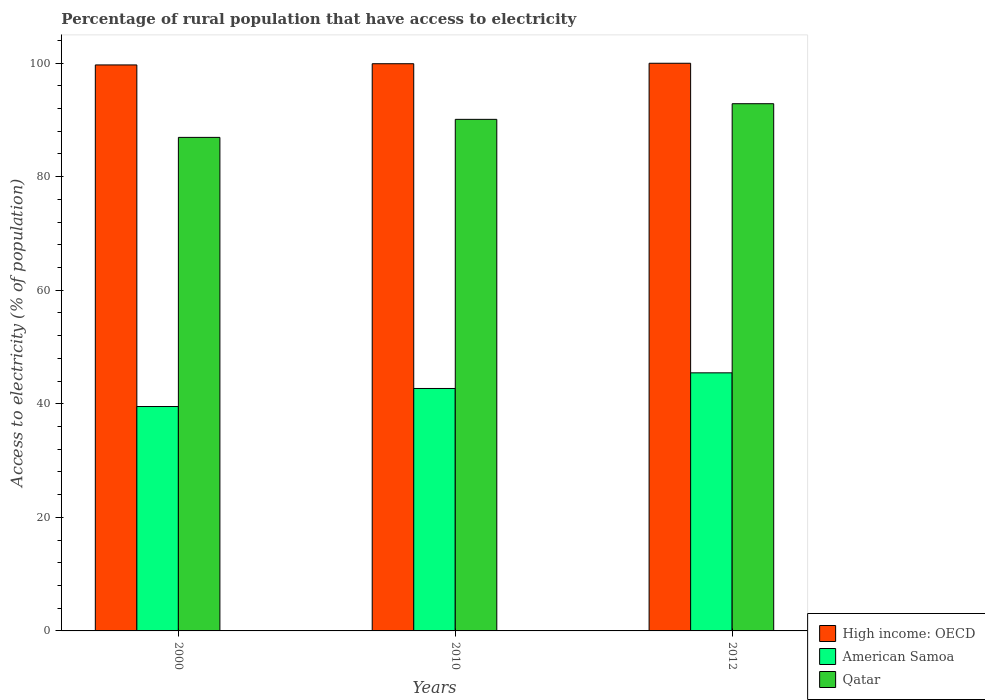How many groups of bars are there?
Ensure brevity in your answer.  3. What is the label of the 2nd group of bars from the left?
Keep it short and to the point. 2010. What is the percentage of rural population that have access to electricity in High income: OECD in 2012?
Ensure brevity in your answer.  99.98. Across all years, what is the maximum percentage of rural population that have access to electricity in American Samoa?
Keep it short and to the point. 45.45. Across all years, what is the minimum percentage of rural population that have access to electricity in American Samoa?
Make the answer very short. 39.52. What is the total percentage of rural population that have access to electricity in American Samoa in the graph?
Keep it short and to the point. 127.68. What is the difference between the percentage of rural population that have access to electricity in High income: OECD in 2010 and that in 2012?
Provide a short and direct response. -0.08. What is the difference between the percentage of rural population that have access to electricity in High income: OECD in 2010 and the percentage of rural population that have access to electricity in Qatar in 2012?
Your response must be concise. 7.04. What is the average percentage of rural population that have access to electricity in American Samoa per year?
Give a very brief answer. 42.56. In the year 2012, what is the difference between the percentage of rural population that have access to electricity in Qatar and percentage of rural population that have access to electricity in High income: OECD?
Keep it short and to the point. -7.13. In how many years, is the percentage of rural population that have access to electricity in High income: OECD greater than 80 %?
Offer a very short reply. 3. What is the ratio of the percentage of rural population that have access to electricity in High income: OECD in 2000 to that in 2010?
Make the answer very short. 1. What is the difference between the highest and the second highest percentage of rural population that have access to electricity in Qatar?
Provide a short and direct response. 2.75. What is the difference between the highest and the lowest percentage of rural population that have access to electricity in High income: OECD?
Offer a terse response. 0.3. What does the 2nd bar from the left in 2010 represents?
Offer a terse response. American Samoa. What does the 3rd bar from the right in 2000 represents?
Offer a very short reply. High income: OECD. Is it the case that in every year, the sum of the percentage of rural population that have access to electricity in Qatar and percentage of rural population that have access to electricity in High income: OECD is greater than the percentage of rural population that have access to electricity in American Samoa?
Keep it short and to the point. Yes. Are all the bars in the graph horizontal?
Provide a short and direct response. No. Are the values on the major ticks of Y-axis written in scientific E-notation?
Provide a short and direct response. No. How many legend labels are there?
Provide a short and direct response. 3. What is the title of the graph?
Provide a short and direct response. Percentage of rural population that have access to electricity. Does "Zimbabwe" appear as one of the legend labels in the graph?
Give a very brief answer. No. What is the label or title of the X-axis?
Provide a succinct answer. Years. What is the label or title of the Y-axis?
Your answer should be compact. Access to electricity (% of population). What is the Access to electricity (% of population) of High income: OECD in 2000?
Give a very brief answer. 99.68. What is the Access to electricity (% of population) in American Samoa in 2000?
Keep it short and to the point. 39.52. What is the Access to electricity (% of population) of Qatar in 2000?
Give a very brief answer. 86.93. What is the Access to electricity (% of population) of High income: OECD in 2010?
Make the answer very short. 99.9. What is the Access to electricity (% of population) of American Samoa in 2010?
Provide a succinct answer. 42.7. What is the Access to electricity (% of population) of Qatar in 2010?
Offer a terse response. 90.1. What is the Access to electricity (% of population) in High income: OECD in 2012?
Give a very brief answer. 99.98. What is the Access to electricity (% of population) of American Samoa in 2012?
Offer a terse response. 45.45. What is the Access to electricity (% of population) of Qatar in 2012?
Offer a terse response. 92.85. Across all years, what is the maximum Access to electricity (% of population) of High income: OECD?
Give a very brief answer. 99.98. Across all years, what is the maximum Access to electricity (% of population) in American Samoa?
Keep it short and to the point. 45.45. Across all years, what is the maximum Access to electricity (% of population) in Qatar?
Make the answer very short. 92.85. Across all years, what is the minimum Access to electricity (% of population) of High income: OECD?
Ensure brevity in your answer.  99.68. Across all years, what is the minimum Access to electricity (% of population) of American Samoa?
Offer a very short reply. 39.52. Across all years, what is the minimum Access to electricity (% of population) of Qatar?
Your response must be concise. 86.93. What is the total Access to electricity (% of population) in High income: OECD in the graph?
Your response must be concise. 299.56. What is the total Access to electricity (% of population) of American Samoa in the graph?
Make the answer very short. 127.68. What is the total Access to electricity (% of population) in Qatar in the graph?
Make the answer very short. 269.88. What is the difference between the Access to electricity (% of population) in High income: OECD in 2000 and that in 2010?
Keep it short and to the point. -0.21. What is the difference between the Access to electricity (% of population) of American Samoa in 2000 and that in 2010?
Offer a terse response. -3.18. What is the difference between the Access to electricity (% of population) of Qatar in 2000 and that in 2010?
Provide a succinct answer. -3.17. What is the difference between the Access to electricity (% of population) in High income: OECD in 2000 and that in 2012?
Provide a succinct answer. -0.3. What is the difference between the Access to electricity (% of population) in American Samoa in 2000 and that in 2012?
Give a very brief answer. -5.93. What is the difference between the Access to electricity (% of population) in Qatar in 2000 and that in 2012?
Make the answer very short. -5.93. What is the difference between the Access to electricity (% of population) in High income: OECD in 2010 and that in 2012?
Provide a short and direct response. -0.08. What is the difference between the Access to electricity (% of population) in American Samoa in 2010 and that in 2012?
Offer a terse response. -2.75. What is the difference between the Access to electricity (% of population) of Qatar in 2010 and that in 2012?
Offer a terse response. -2.75. What is the difference between the Access to electricity (% of population) in High income: OECD in 2000 and the Access to electricity (% of population) in American Samoa in 2010?
Keep it short and to the point. 56.98. What is the difference between the Access to electricity (% of population) of High income: OECD in 2000 and the Access to electricity (% of population) of Qatar in 2010?
Give a very brief answer. 9.58. What is the difference between the Access to electricity (% of population) in American Samoa in 2000 and the Access to electricity (% of population) in Qatar in 2010?
Your answer should be very brief. -50.58. What is the difference between the Access to electricity (% of population) of High income: OECD in 2000 and the Access to electricity (% of population) of American Samoa in 2012?
Your answer should be very brief. 54.23. What is the difference between the Access to electricity (% of population) in High income: OECD in 2000 and the Access to electricity (% of population) in Qatar in 2012?
Ensure brevity in your answer.  6.83. What is the difference between the Access to electricity (% of population) in American Samoa in 2000 and the Access to electricity (% of population) in Qatar in 2012?
Make the answer very short. -53.33. What is the difference between the Access to electricity (% of population) of High income: OECD in 2010 and the Access to electricity (% of population) of American Samoa in 2012?
Provide a succinct answer. 54.44. What is the difference between the Access to electricity (% of population) in High income: OECD in 2010 and the Access to electricity (% of population) in Qatar in 2012?
Offer a terse response. 7.04. What is the difference between the Access to electricity (% of population) in American Samoa in 2010 and the Access to electricity (% of population) in Qatar in 2012?
Your answer should be very brief. -50.15. What is the average Access to electricity (% of population) in High income: OECD per year?
Provide a succinct answer. 99.85. What is the average Access to electricity (% of population) in American Samoa per year?
Offer a very short reply. 42.56. What is the average Access to electricity (% of population) of Qatar per year?
Your answer should be very brief. 89.96. In the year 2000, what is the difference between the Access to electricity (% of population) of High income: OECD and Access to electricity (% of population) of American Samoa?
Offer a terse response. 60.16. In the year 2000, what is the difference between the Access to electricity (% of population) in High income: OECD and Access to electricity (% of population) in Qatar?
Offer a very short reply. 12.76. In the year 2000, what is the difference between the Access to electricity (% of population) of American Samoa and Access to electricity (% of population) of Qatar?
Your response must be concise. -47.41. In the year 2010, what is the difference between the Access to electricity (% of population) in High income: OECD and Access to electricity (% of population) in American Samoa?
Give a very brief answer. 57.2. In the year 2010, what is the difference between the Access to electricity (% of population) in High income: OECD and Access to electricity (% of population) in Qatar?
Give a very brief answer. 9.8. In the year 2010, what is the difference between the Access to electricity (% of population) of American Samoa and Access to electricity (% of population) of Qatar?
Offer a very short reply. -47.4. In the year 2012, what is the difference between the Access to electricity (% of population) of High income: OECD and Access to electricity (% of population) of American Samoa?
Ensure brevity in your answer.  54.53. In the year 2012, what is the difference between the Access to electricity (% of population) in High income: OECD and Access to electricity (% of population) in Qatar?
Your answer should be very brief. 7.13. In the year 2012, what is the difference between the Access to electricity (% of population) in American Samoa and Access to electricity (% of population) in Qatar?
Keep it short and to the point. -47.4. What is the ratio of the Access to electricity (% of population) of American Samoa in 2000 to that in 2010?
Ensure brevity in your answer.  0.93. What is the ratio of the Access to electricity (% of population) of Qatar in 2000 to that in 2010?
Your answer should be compact. 0.96. What is the ratio of the Access to electricity (% of population) in American Samoa in 2000 to that in 2012?
Your answer should be compact. 0.87. What is the ratio of the Access to electricity (% of population) in Qatar in 2000 to that in 2012?
Provide a succinct answer. 0.94. What is the ratio of the Access to electricity (% of population) of High income: OECD in 2010 to that in 2012?
Provide a short and direct response. 1. What is the ratio of the Access to electricity (% of population) in American Samoa in 2010 to that in 2012?
Your answer should be very brief. 0.94. What is the ratio of the Access to electricity (% of population) in Qatar in 2010 to that in 2012?
Keep it short and to the point. 0.97. What is the difference between the highest and the second highest Access to electricity (% of population) of High income: OECD?
Your response must be concise. 0.08. What is the difference between the highest and the second highest Access to electricity (% of population) in American Samoa?
Provide a short and direct response. 2.75. What is the difference between the highest and the second highest Access to electricity (% of population) in Qatar?
Provide a short and direct response. 2.75. What is the difference between the highest and the lowest Access to electricity (% of population) in High income: OECD?
Provide a succinct answer. 0.3. What is the difference between the highest and the lowest Access to electricity (% of population) of American Samoa?
Give a very brief answer. 5.93. What is the difference between the highest and the lowest Access to electricity (% of population) in Qatar?
Ensure brevity in your answer.  5.93. 